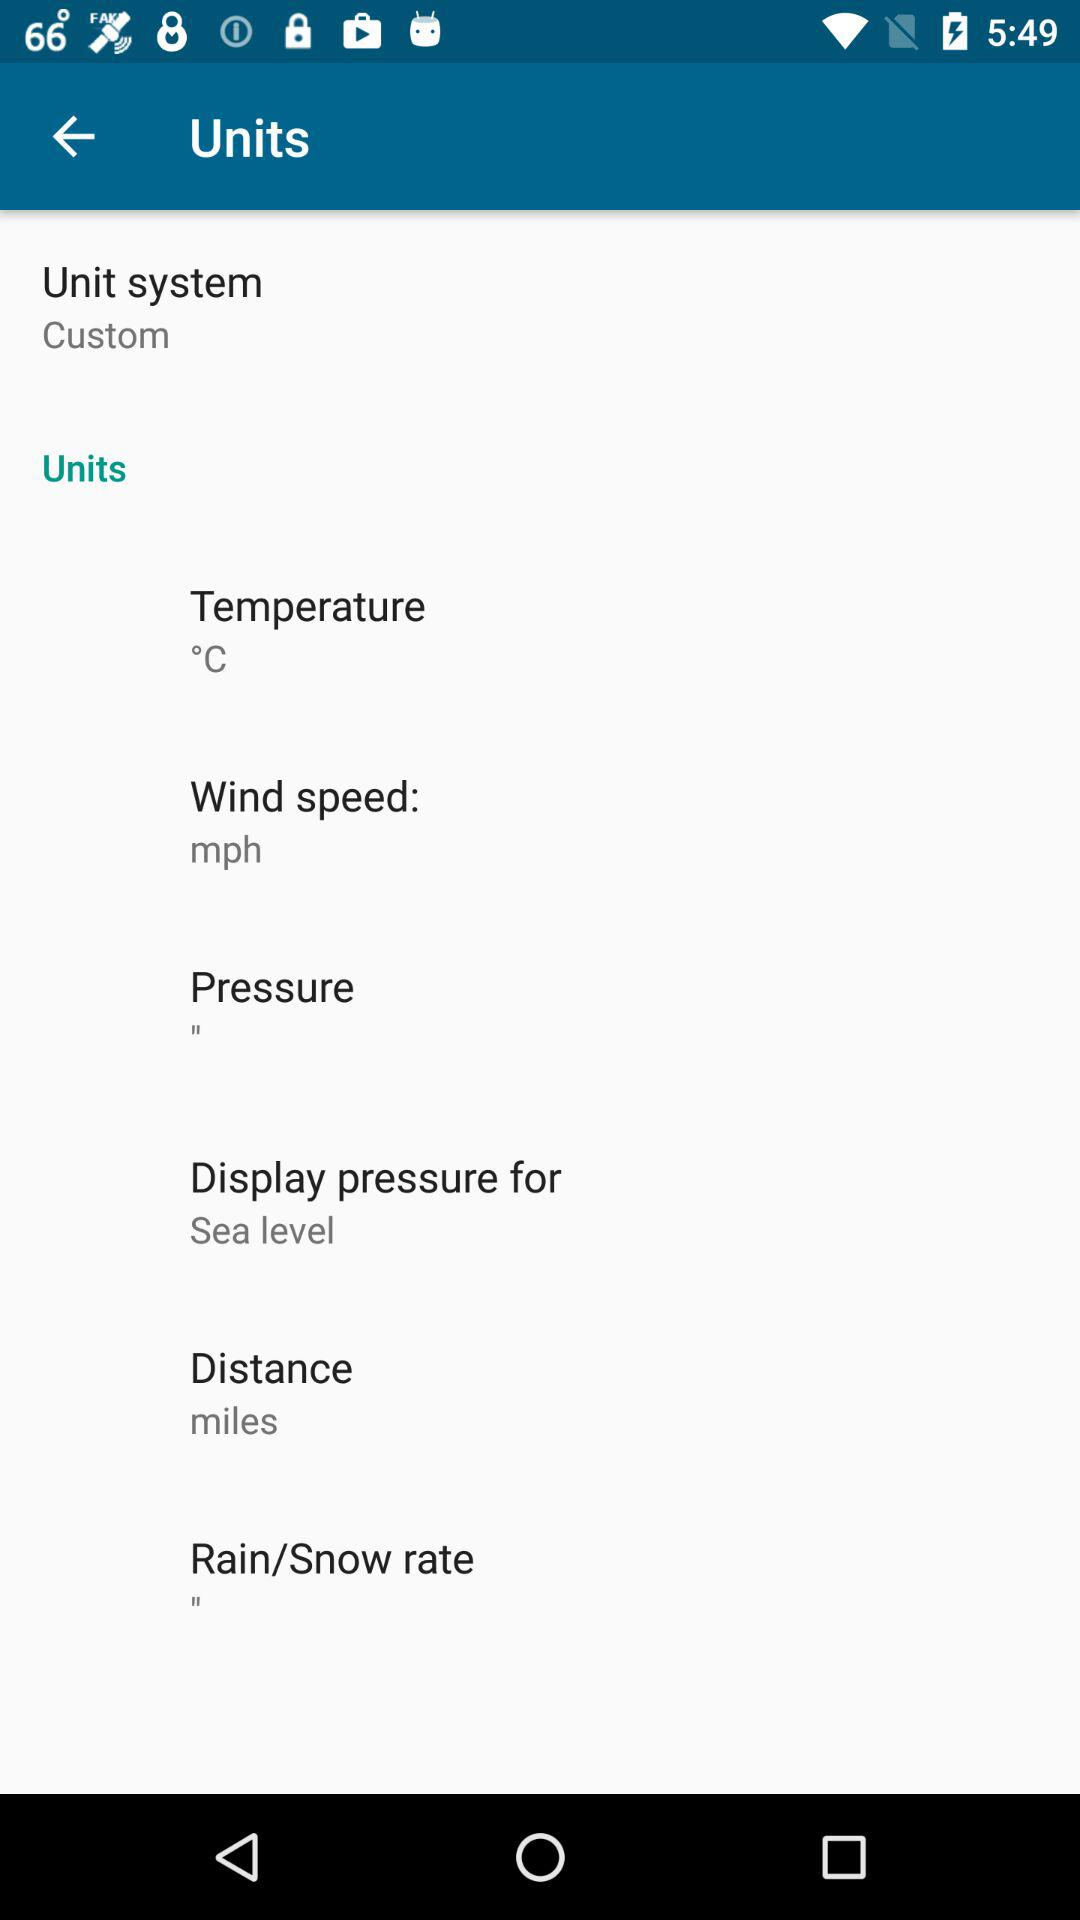What is the unit for wind speed? The unit for wind speed is mph. 